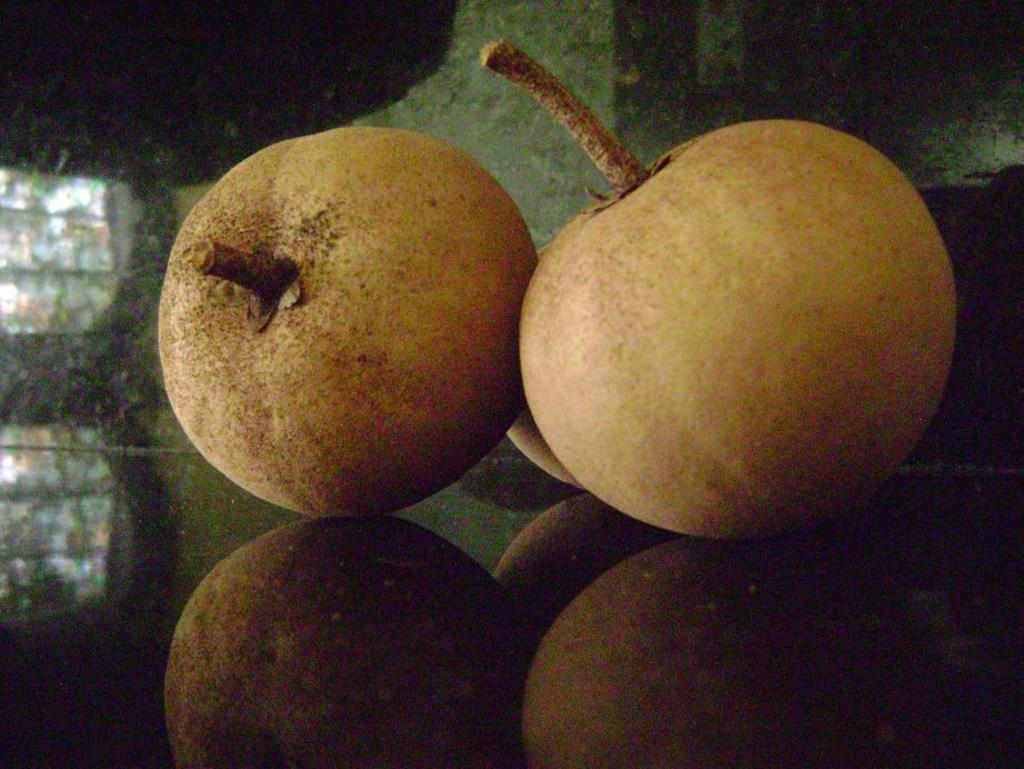How many fruits are visible in the image? There are three fruits in the image. Where are the fruits placed in the image? The fruits are kept on a surface. Can you describe any additional features related to the fruits in the image? Yes, there is a reflection of the fruits on the surface. What type of sail can be seen on the dress of the achiever in the image? There is no sail, dress, or achiever present in the image; it only features three fruits on a surface. 